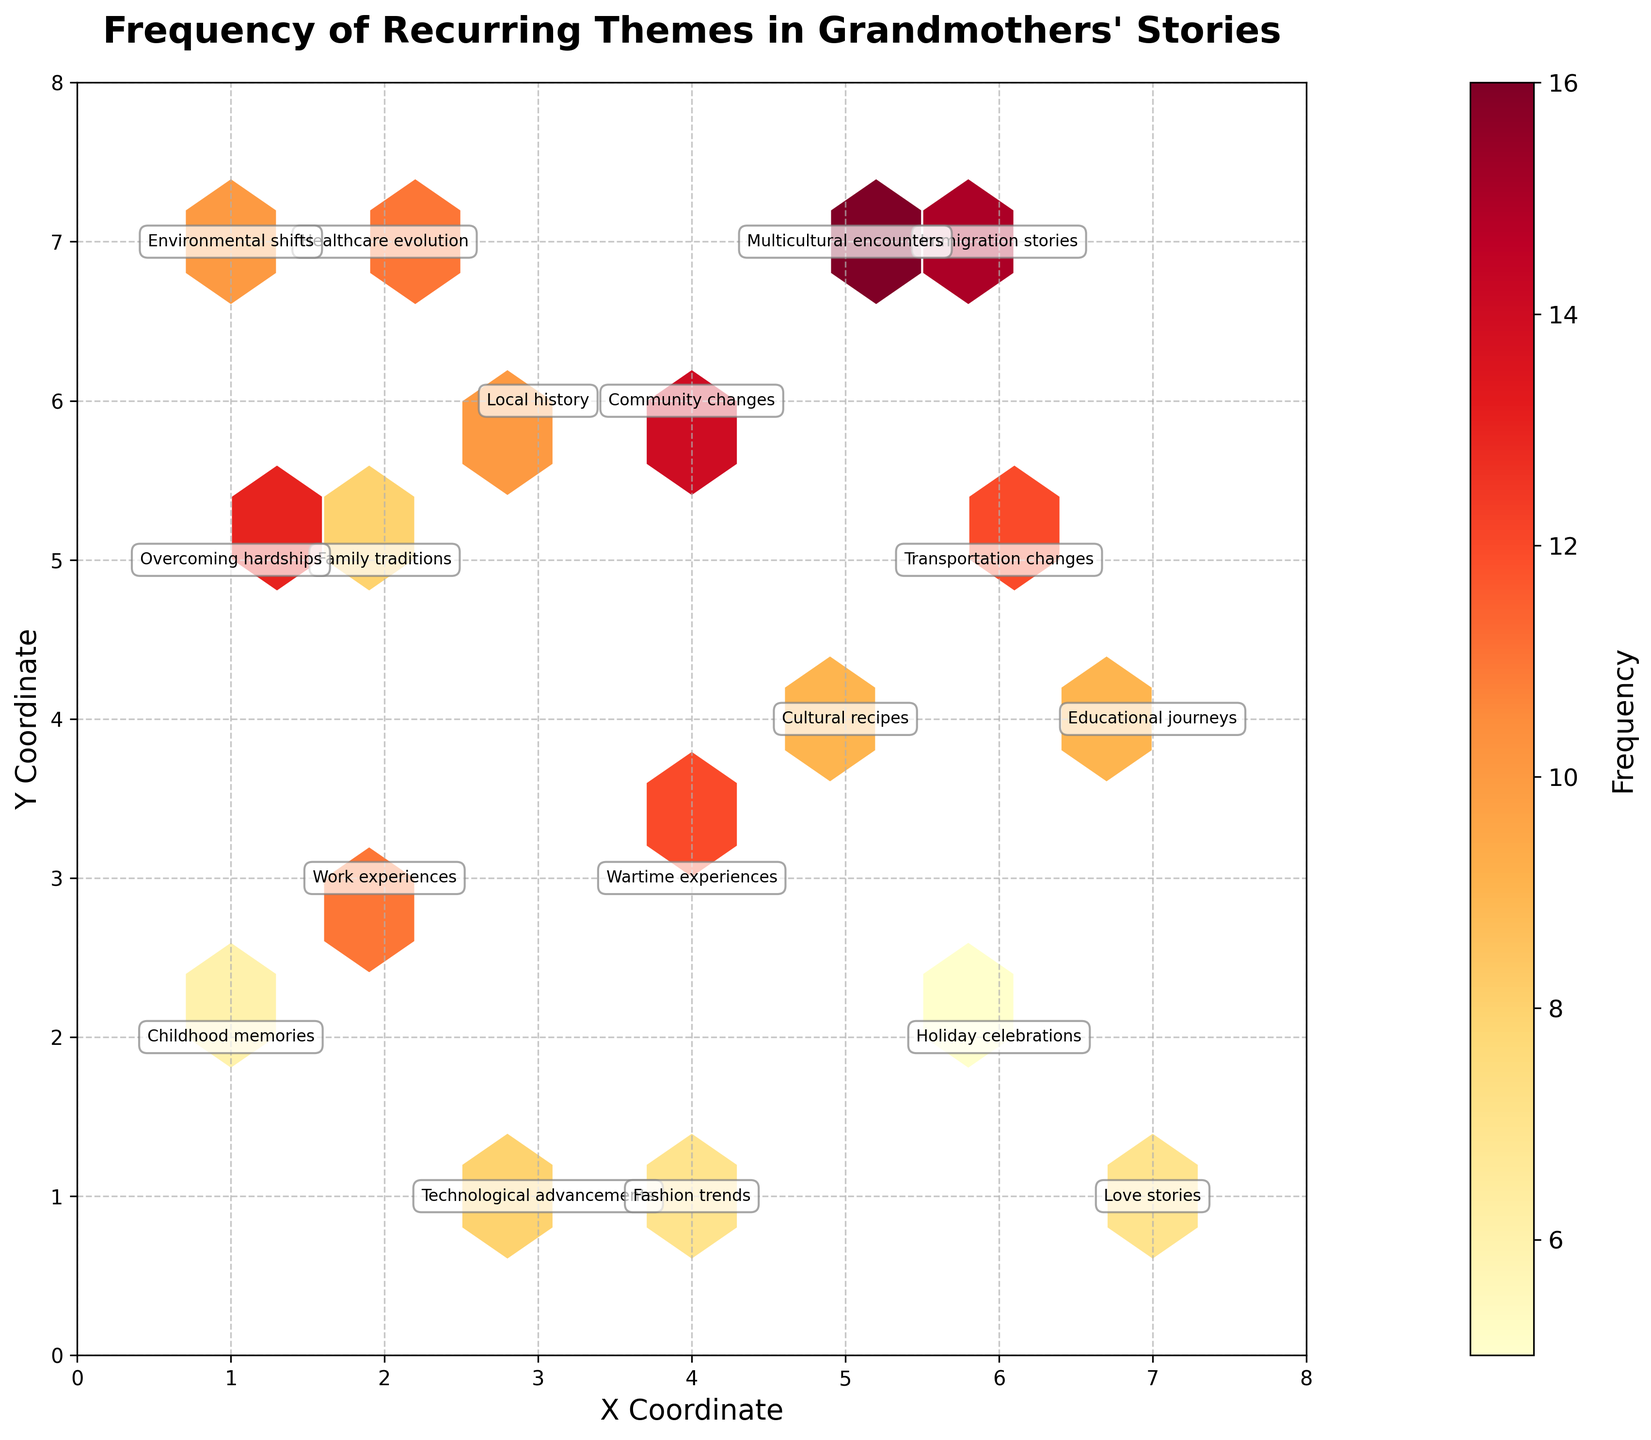How many distinct neighborhoods are presented in the plot? The figure annotates different themes in various coordinates. Counting the unique occurrences of neighborhood names in the annotations gives us the total number of distinct neighborhoods.
Answer: 18 Which neighborhood has the highest frequency of recurring themes? Inspect the color intensity in the hexbin plot and the frequency annotations. Identify the hexagon with the highest frequency number.
Answer: Greektown What theme is associated with the highest frequency in the plot? Look for the hexagon with the highest value and read its corresponding theme from the annotation.
Answer: Multicultural encounters What is the average frequency of all recurring themes in the plot? Sum the frequency values from the annotations and divide by the total number of data points. (8+12+15+6+10+9+7+11+14+5+13+8+16+9+11+7+12+10)/18 = 155/18 = ~8.61
Answer: ~8.61 Compare the frequency of 'Family traditions' in Brookside and 'Technological advancements' in Liberty Village. Which is higher and by how much? Refer to the annotations for 'Family traditions' and 'Technological advancements', then calculate the difference in their frequency values. 8 (Family traditions) - 8 (Technological advancements) = 0
Answer: They are equal What is the most commonly recurring theme in Roncesvalles according to the plot? Locate the hexbin annotation for Roncesvalles to find its specific theme and frequency.
Answer: Community changes Which two themes appear in neighborhoods with different coordinates but the same frequency? Identify themes by comparing frequencies across different coordinates. 'Multicultural encounters' in Greektown and 'Community changes' in Roncesvalles both have a frequency of 16.
Answer: Multicultural encounters and Community changes Of the neighborhoods listed, which has the lowest frequency of recurring themes, and what is the frequency? Identify the lowest frequency annotation among the neighborhoods.
Answer: The Beaches, 5 Is the frequency of 'Wartime experiences' in Oakwood higher or lower than the frequency of 'Healthcare evolution' in Cabbagetown? By how much? Compare the frequencies in the annotations for 'Wartime experiences' and 'Healthcare evolution'. 12 (Wartime experiences) - 11 (Healthcare evolution) = 1
Answer: Higher by 1 How does the frequency of 'Educational journeys' in The Annex compare to 'Cultural recipes' in Chinatown? Locate the annotations and compare the frequencies of 'Educational journeys' and 'Cultural recipes'. 9 (Educational journeys) - 9 (Cultural recipes) = 0
Answer: They are equal 